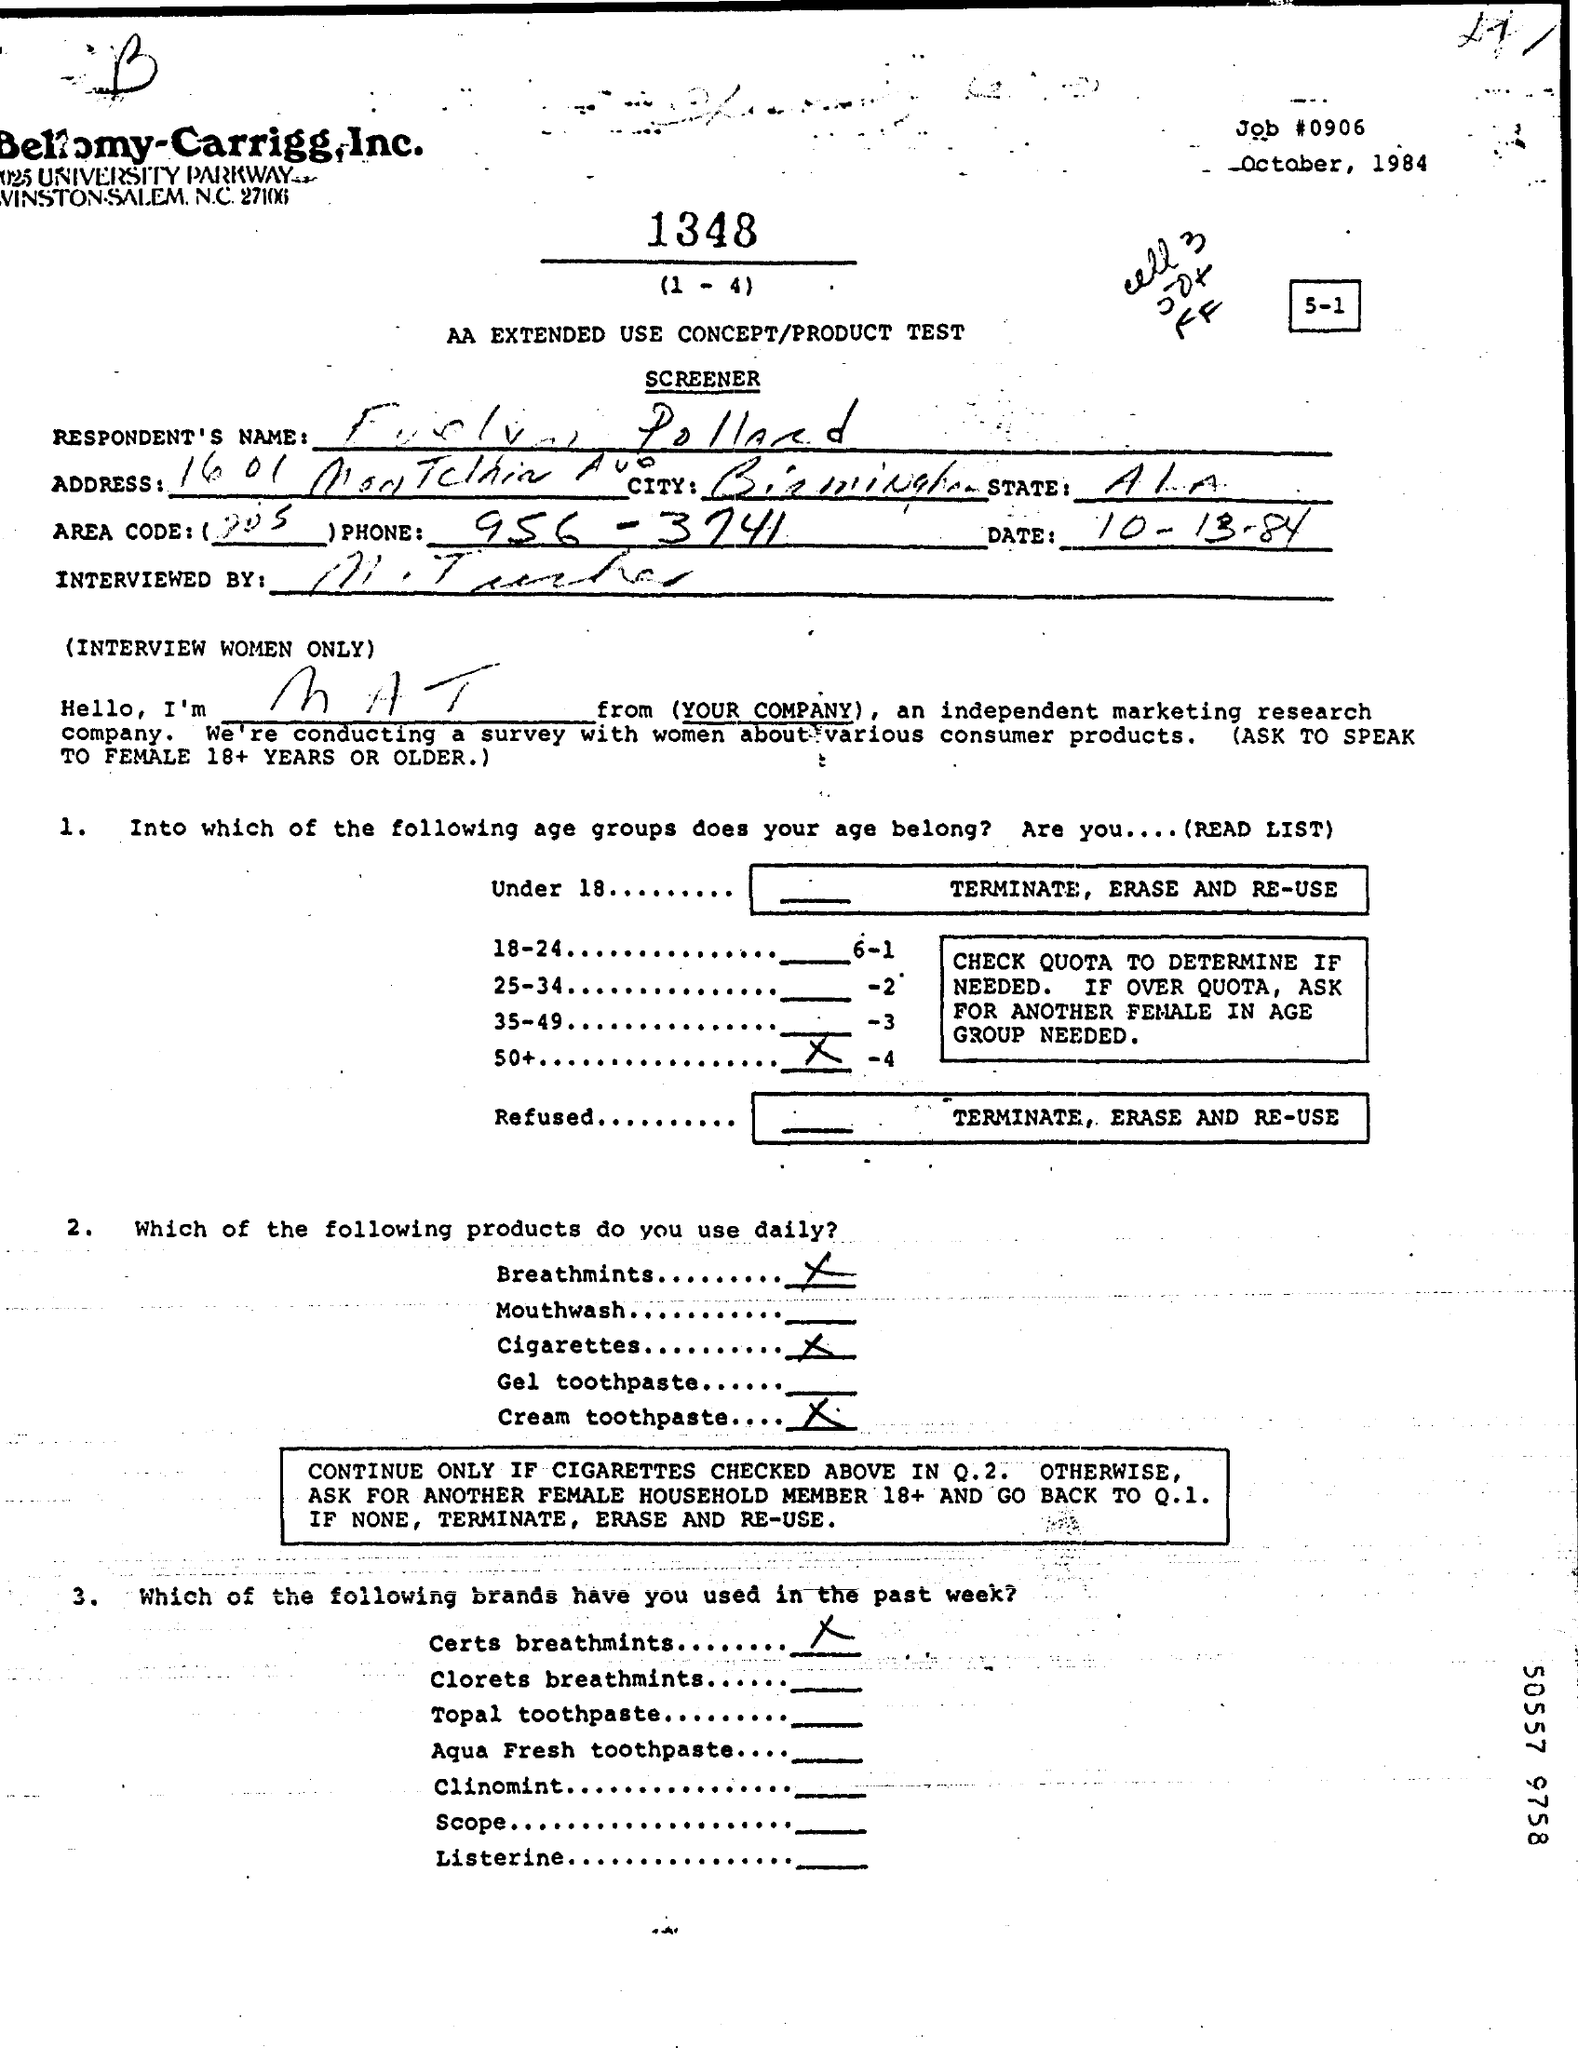What is the Job#?
Give a very brief answer. 0906. What is the Date?
Your response must be concise. 10-13-84. What is the Phone?
Provide a succinct answer. 956-3741. 